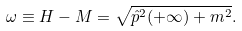Convert formula to latex. <formula><loc_0><loc_0><loc_500><loc_500>\omega \equiv H - M = \sqrt { \hat { p } ^ { 2 } ( + \infty ) + m ^ { 2 } } .</formula> 